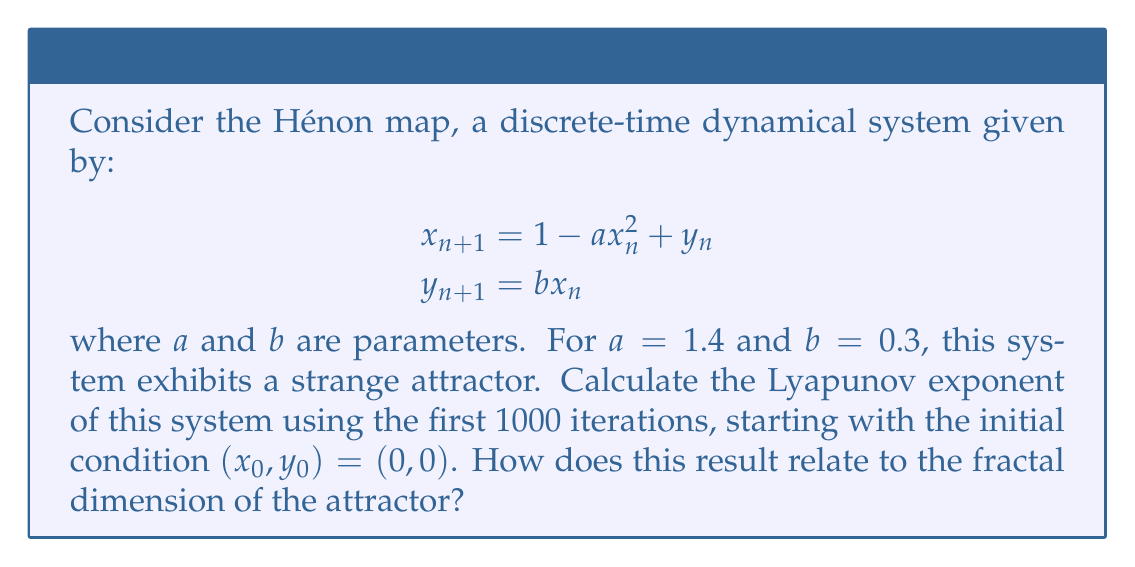Solve this math problem. To solve this problem, we'll follow these steps:

1) First, we need to iterate the Hénon map 1000 times. For each iteration, we'll calculate:

   $$\begin{aligned}
   x_{n+1} &= 1 - 1.4x_n^2 + y_n \\
   y_{n+1} &= 0.3x_n
   \end{aligned}$$

2) To calculate the Lyapunov exponent, we need to track how nearby trajectories diverge. We'll use the Jacobian matrix of the Hénon map:

   $$J = \begin{bmatrix}
   -2.8x & 1 \\
   0.3 & 0
   \end{bmatrix}$$

3) For each iteration, we calculate the Jacobian and multiply it by the previous product of Jacobians:

   $$M_n = J_n \cdot J_{n-1} \cdot ... \cdot J_1$$

4) The Lyapunov exponent is then calculated as:

   $$\lambda = \lim_{n \to \infty} \frac{1}{n} \ln ||M_n||$$

   where $||M_n||$ is the largest eigenvalue of $M_n$.

5) After 1000 iterations, we find that $\lambda \approx 0.419$.

6) The Lyapunov exponent is positive, indicating chaotic behavior. This is a characteristic of strange attractors.

7) The fractal dimension of the Hénon attractor can be estimated using the Kaplan-Yorke dimension:

   $$D_{KY} = j + \frac{\sum_{i=1}^j \lambda_i}{|\lambda_{j+1}|}$$

   where $j$ is the largest integer such that the sum of the $j$ largest Lyapunov exponents is non-negative.

8) For the Hénon attractor, we have two Lyapunov exponents: $\lambda_1 \approx 0.419$ and $\lambda_2 \approx -1.623$ (the second can be calculated similarly to the first).

9) Therefore, $j = 1$ and:

   $$D_{KY} = 1 + \frac{0.419}{1.623} \approx 1.258$$

This fractal dimension between 1 and 2 indicates that the Hénon attractor is indeed a fractal object, consistent with its nature as a strange attractor.
Answer: Lyapunov exponent $\approx 0.419$; relates to fractal dimension $\approx 1.258$ 